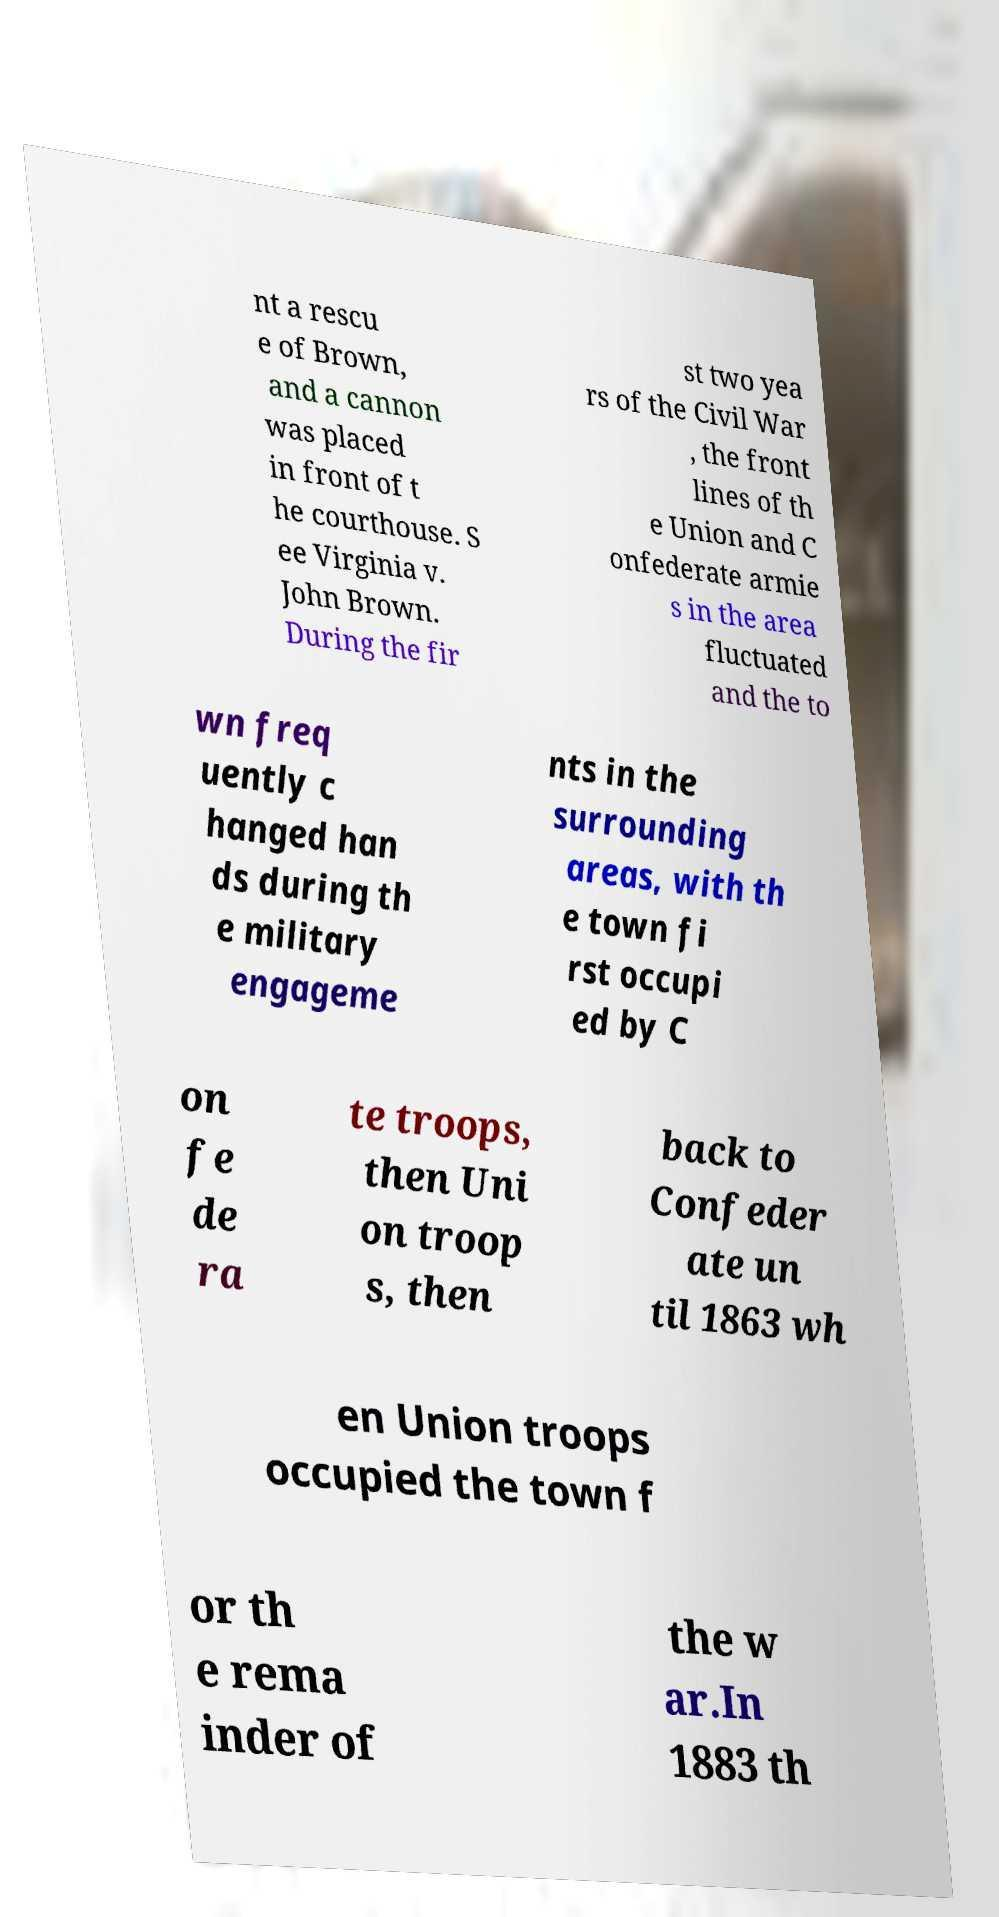Can you accurately transcribe the text from the provided image for me? nt a rescu e of Brown, and a cannon was placed in front of t he courthouse. S ee Virginia v. John Brown. During the fir st two yea rs of the Civil War , the front lines of th e Union and C onfederate armie s in the area fluctuated and the to wn freq uently c hanged han ds during th e military engageme nts in the surrounding areas, with th e town fi rst occupi ed by C on fe de ra te troops, then Uni on troop s, then back to Confeder ate un til 1863 wh en Union troops occupied the town f or th e rema inder of the w ar.In 1883 th 